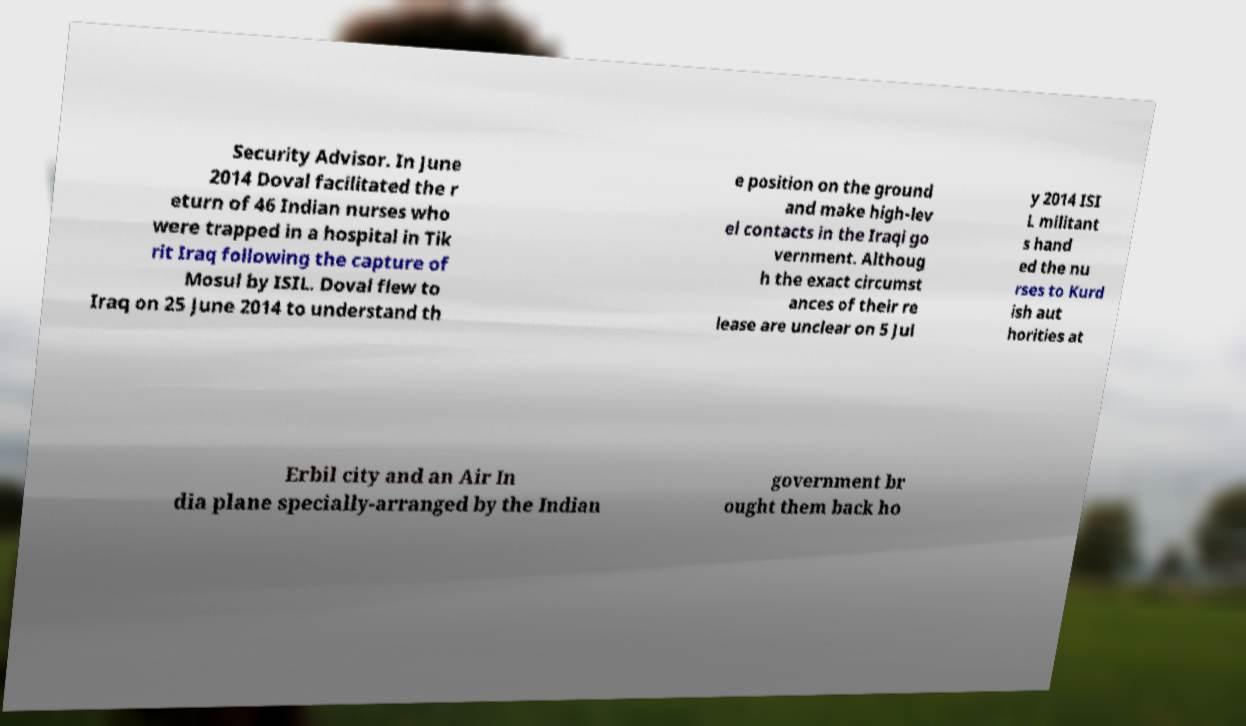There's text embedded in this image that I need extracted. Can you transcribe it verbatim? Security Advisor. In June 2014 Doval facilitated the r eturn of 46 Indian nurses who were trapped in a hospital in Tik rit Iraq following the capture of Mosul by ISIL. Doval flew to Iraq on 25 June 2014 to understand th e position on the ground and make high-lev el contacts in the Iraqi go vernment. Althoug h the exact circumst ances of their re lease are unclear on 5 Jul y 2014 ISI L militant s hand ed the nu rses to Kurd ish aut horities at Erbil city and an Air In dia plane specially-arranged by the Indian government br ought them back ho 